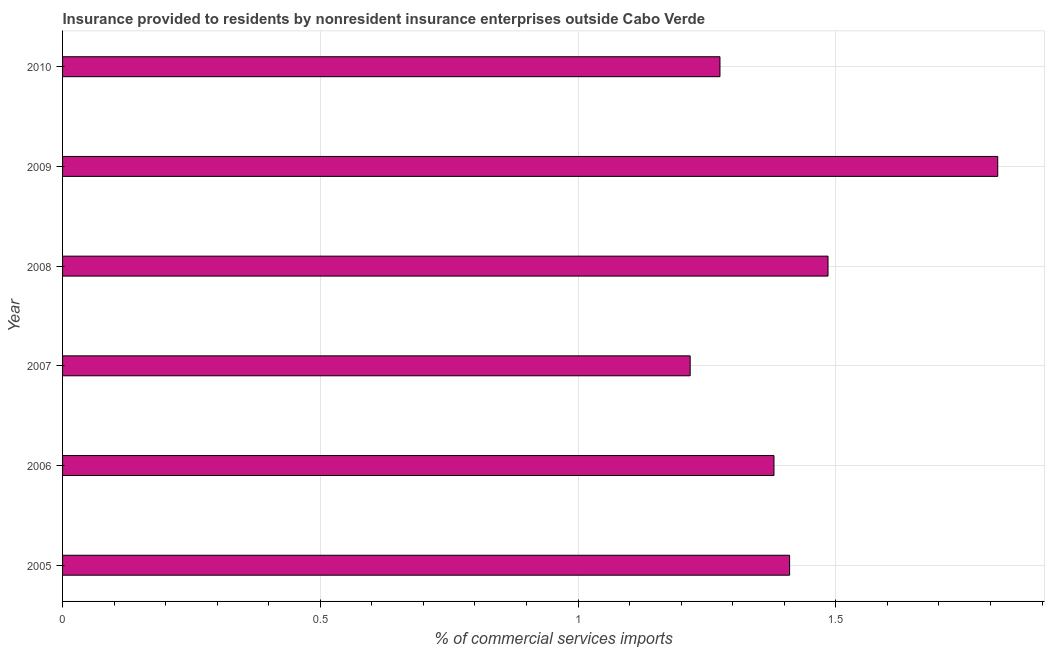Does the graph contain any zero values?
Offer a very short reply. No. Does the graph contain grids?
Offer a very short reply. Yes. What is the title of the graph?
Provide a short and direct response. Insurance provided to residents by nonresident insurance enterprises outside Cabo Verde. What is the label or title of the X-axis?
Your response must be concise. % of commercial services imports. What is the insurance provided by non-residents in 2008?
Provide a succinct answer. 1.48. Across all years, what is the maximum insurance provided by non-residents?
Offer a very short reply. 1.81. Across all years, what is the minimum insurance provided by non-residents?
Your response must be concise. 1.22. In which year was the insurance provided by non-residents maximum?
Keep it short and to the point. 2009. What is the sum of the insurance provided by non-residents?
Give a very brief answer. 8.58. What is the difference between the insurance provided by non-residents in 2007 and 2010?
Keep it short and to the point. -0.06. What is the average insurance provided by non-residents per year?
Provide a short and direct response. 1.43. What is the median insurance provided by non-residents?
Your response must be concise. 1.4. In how many years, is the insurance provided by non-residents greater than 0.9 %?
Provide a short and direct response. 6. What is the ratio of the insurance provided by non-residents in 2007 to that in 2009?
Offer a very short reply. 0.67. Is the insurance provided by non-residents in 2006 less than that in 2010?
Offer a terse response. No. What is the difference between the highest and the second highest insurance provided by non-residents?
Offer a very short reply. 0.33. In how many years, is the insurance provided by non-residents greater than the average insurance provided by non-residents taken over all years?
Provide a short and direct response. 2. How many bars are there?
Your answer should be compact. 6. What is the difference between two consecutive major ticks on the X-axis?
Offer a terse response. 0.5. What is the % of commercial services imports of 2005?
Ensure brevity in your answer.  1.41. What is the % of commercial services imports in 2006?
Offer a terse response. 1.38. What is the % of commercial services imports in 2007?
Offer a very short reply. 1.22. What is the % of commercial services imports in 2008?
Keep it short and to the point. 1.48. What is the % of commercial services imports in 2009?
Provide a short and direct response. 1.81. What is the % of commercial services imports in 2010?
Offer a very short reply. 1.28. What is the difference between the % of commercial services imports in 2005 and 2006?
Provide a succinct answer. 0.03. What is the difference between the % of commercial services imports in 2005 and 2007?
Offer a very short reply. 0.19. What is the difference between the % of commercial services imports in 2005 and 2008?
Provide a short and direct response. -0.07. What is the difference between the % of commercial services imports in 2005 and 2009?
Your answer should be compact. -0.4. What is the difference between the % of commercial services imports in 2005 and 2010?
Keep it short and to the point. 0.14. What is the difference between the % of commercial services imports in 2006 and 2007?
Provide a short and direct response. 0.16. What is the difference between the % of commercial services imports in 2006 and 2008?
Your answer should be very brief. -0.1. What is the difference between the % of commercial services imports in 2006 and 2009?
Offer a very short reply. -0.43. What is the difference between the % of commercial services imports in 2006 and 2010?
Provide a short and direct response. 0.1. What is the difference between the % of commercial services imports in 2007 and 2008?
Make the answer very short. -0.27. What is the difference between the % of commercial services imports in 2007 and 2009?
Your answer should be compact. -0.6. What is the difference between the % of commercial services imports in 2007 and 2010?
Provide a short and direct response. -0.06. What is the difference between the % of commercial services imports in 2008 and 2009?
Give a very brief answer. -0.33. What is the difference between the % of commercial services imports in 2008 and 2010?
Make the answer very short. 0.21. What is the difference between the % of commercial services imports in 2009 and 2010?
Your answer should be very brief. 0.54. What is the ratio of the % of commercial services imports in 2005 to that in 2007?
Offer a very short reply. 1.16. What is the ratio of the % of commercial services imports in 2005 to that in 2009?
Offer a very short reply. 0.78. What is the ratio of the % of commercial services imports in 2005 to that in 2010?
Ensure brevity in your answer.  1.11. What is the ratio of the % of commercial services imports in 2006 to that in 2007?
Your response must be concise. 1.13. What is the ratio of the % of commercial services imports in 2006 to that in 2008?
Give a very brief answer. 0.93. What is the ratio of the % of commercial services imports in 2006 to that in 2009?
Make the answer very short. 0.76. What is the ratio of the % of commercial services imports in 2006 to that in 2010?
Your response must be concise. 1.08. What is the ratio of the % of commercial services imports in 2007 to that in 2008?
Offer a terse response. 0.82. What is the ratio of the % of commercial services imports in 2007 to that in 2009?
Offer a very short reply. 0.67. What is the ratio of the % of commercial services imports in 2007 to that in 2010?
Ensure brevity in your answer.  0.95. What is the ratio of the % of commercial services imports in 2008 to that in 2009?
Your answer should be compact. 0.82. What is the ratio of the % of commercial services imports in 2008 to that in 2010?
Give a very brief answer. 1.16. What is the ratio of the % of commercial services imports in 2009 to that in 2010?
Your answer should be compact. 1.42. 